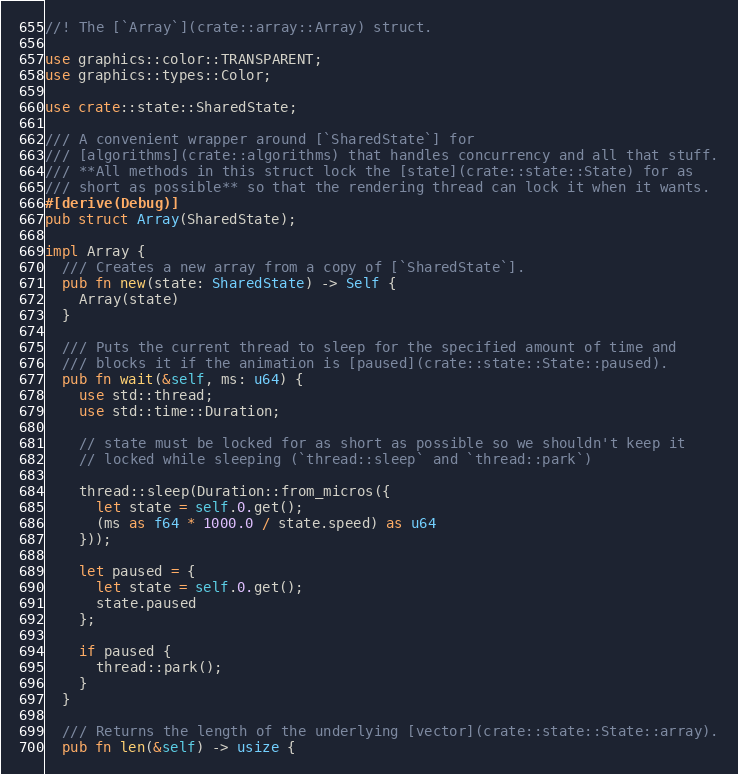Convert code to text. <code><loc_0><loc_0><loc_500><loc_500><_Rust_>//! The [`Array`](crate::array::Array) struct.

use graphics::color::TRANSPARENT;
use graphics::types::Color;

use crate::state::SharedState;

/// A convenient wrapper around [`SharedState`] for
/// [algorithms](crate::algorithms) that handles concurrency and all that stuff.
/// **All methods in this struct lock the [state](crate::state::State) for as
/// short as possible** so that the rendering thread can lock it when it wants.
#[derive(Debug)]
pub struct Array(SharedState);

impl Array {
  /// Creates a new array from a copy of [`SharedState`].
  pub fn new(state: SharedState) -> Self {
    Array(state)
  }

  /// Puts the current thread to sleep for the specified amount of time and
  /// blocks it if the animation is [paused](crate::state::State::paused).
  pub fn wait(&self, ms: u64) {
    use std::thread;
    use std::time::Duration;

    // state must be locked for as short as possible so we shouldn't keep it
    // locked while sleeping (`thread::sleep` and `thread::park`)

    thread::sleep(Duration::from_micros({
      let state = self.0.get();
      (ms as f64 * 1000.0 / state.speed) as u64
    }));

    let paused = {
      let state = self.0.get();
      state.paused
    };

    if paused {
      thread::park();
    }
  }

  /// Returns the length of the underlying [vector](crate::state::State::array).
  pub fn len(&self) -> usize {</code> 